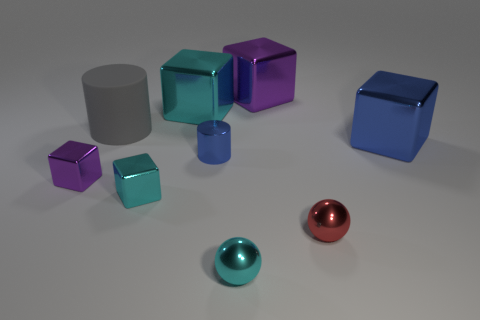Subtract all blue metallic blocks. How many blocks are left? 4 Subtract all blue cubes. How many cubes are left? 4 Subtract all green blocks. Subtract all yellow cylinders. How many blocks are left? 5 Add 1 blocks. How many objects exist? 10 Subtract all balls. How many objects are left? 7 Subtract all big red blocks. Subtract all big metallic blocks. How many objects are left? 6 Add 3 blue metal cubes. How many blue metal cubes are left? 4 Add 9 small matte blocks. How many small matte blocks exist? 9 Subtract 0 green cylinders. How many objects are left? 9 